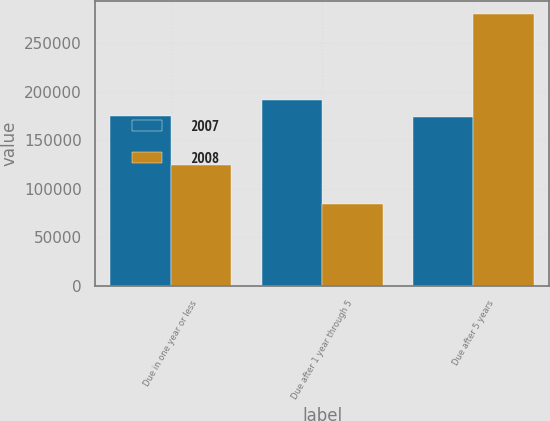<chart> <loc_0><loc_0><loc_500><loc_500><stacked_bar_chart><ecel><fcel>Due in one year or less<fcel>Due after 1 year through 5<fcel>Due after 5 years<nl><fcel>2007<fcel>174710<fcel>191337<fcel>173437<nl><fcel>2008<fcel>124243<fcel>84237<fcel>279950<nl></chart> 